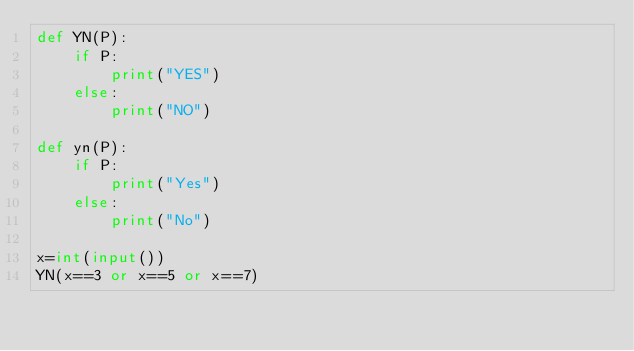Convert code to text. <code><loc_0><loc_0><loc_500><loc_500><_Python_>def YN(P):
    if P:
        print("YES")
    else:
        print("NO")

def yn(P):
    if P:
        print("Yes")
    else:
        print("No")
        
x=int(input())
YN(x==3 or x==5 or x==7)</code> 